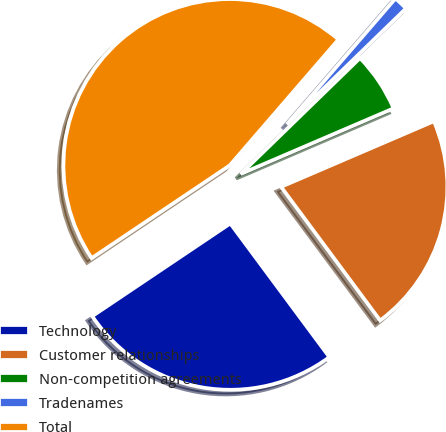Convert chart to OTSL. <chart><loc_0><loc_0><loc_500><loc_500><pie_chart><fcel>Technology<fcel>Customer relationships<fcel>Non-competition agreements<fcel>Tradenames<fcel>Total<nl><fcel>25.74%<fcel>21.3%<fcel>5.82%<fcel>1.39%<fcel>45.75%<nl></chart> 